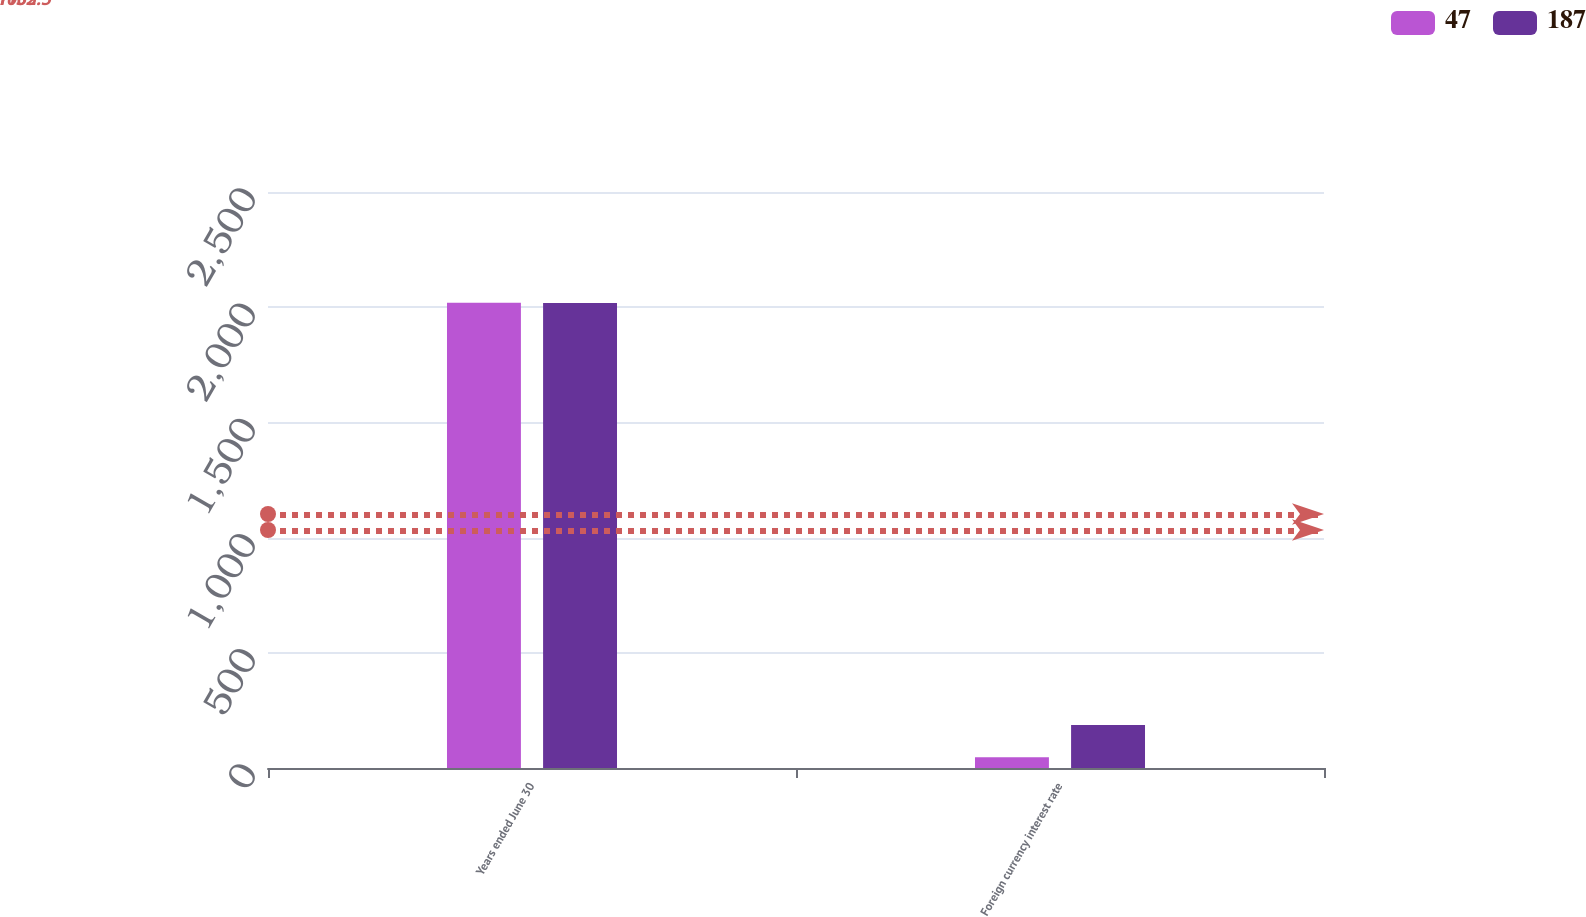<chart> <loc_0><loc_0><loc_500><loc_500><stacked_bar_chart><ecel><fcel>Years ended June 30<fcel>Foreign currency interest rate<nl><fcel>47<fcel>2019<fcel>47<nl><fcel>187<fcel>2018<fcel>187<nl></chart> 